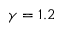<formula> <loc_0><loc_0><loc_500><loc_500>\gamma = 1 . 2</formula> 